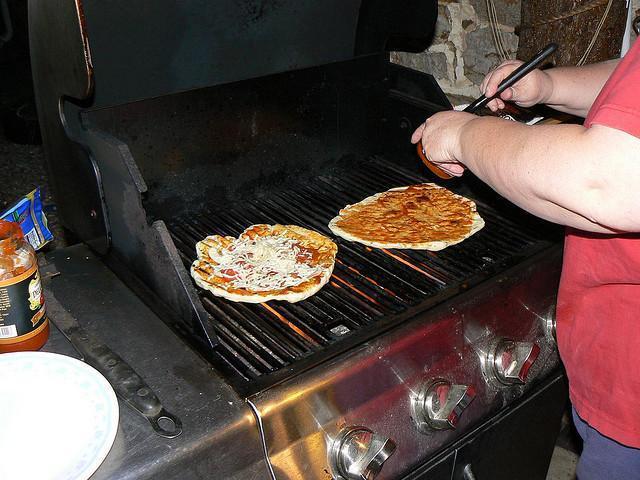How many pizzas can you see?
Give a very brief answer. 2. 